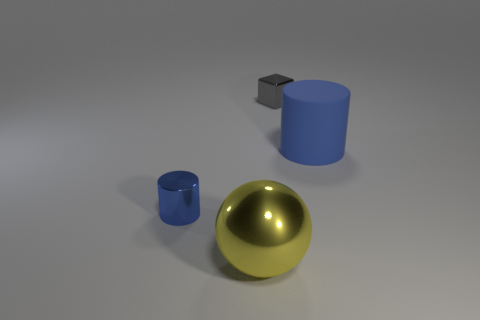How could this setup be used to explain the concept of light and shadows? This setup in the image could be used to demonstrate the behavior of light and how it interacts with different materials to create varying reflections and shadows. The way the light source casts shadows from the objects depending on their shape and position is a practical depiction of basic principles of light in physics. 